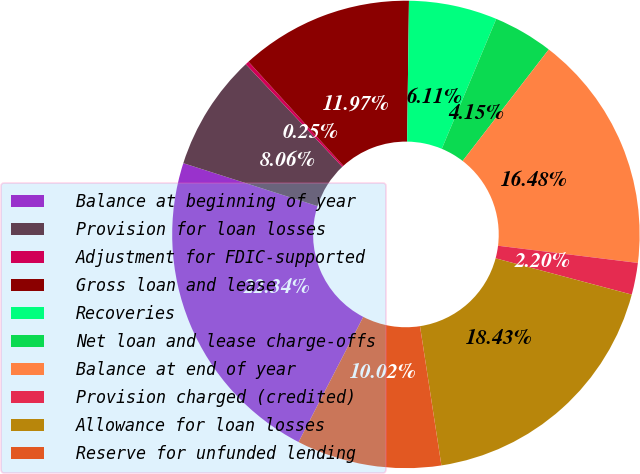<chart> <loc_0><loc_0><loc_500><loc_500><pie_chart><fcel>Balance at beginning of year<fcel>Provision for loan losses<fcel>Adjustment for FDIC-supported<fcel>Gross loan and lease<fcel>Recoveries<fcel>Net loan and lease charge-offs<fcel>Balance at end of year<fcel>Provision charged (credited)<fcel>Allowance for loan losses<fcel>Reserve for unfunded lending<nl><fcel>22.34%<fcel>8.06%<fcel>0.25%<fcel>11.97%<fcel>6.11%<fcel>4.15%<fcel>16.48%<fcel>2.2%<fcel>18.43%<fcel>10.02%<nl></chart> 